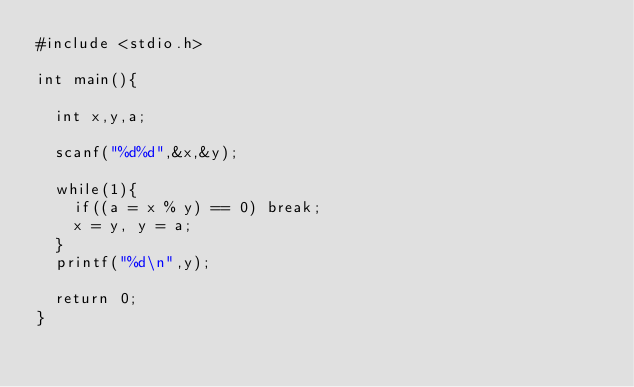Convert code to text. <code><loc_0><loc_0><loc_500><loc_500><_C_>#include <stdio.h>

int main(){

  int x,y,a;

  scanf("%d%d",&x,&y);

  while(1){
    if((a = x % y) == 0) break;
    x = y, y = a;
  }
  printf("%d\n",y);
  
  return 0;
}

</code> 